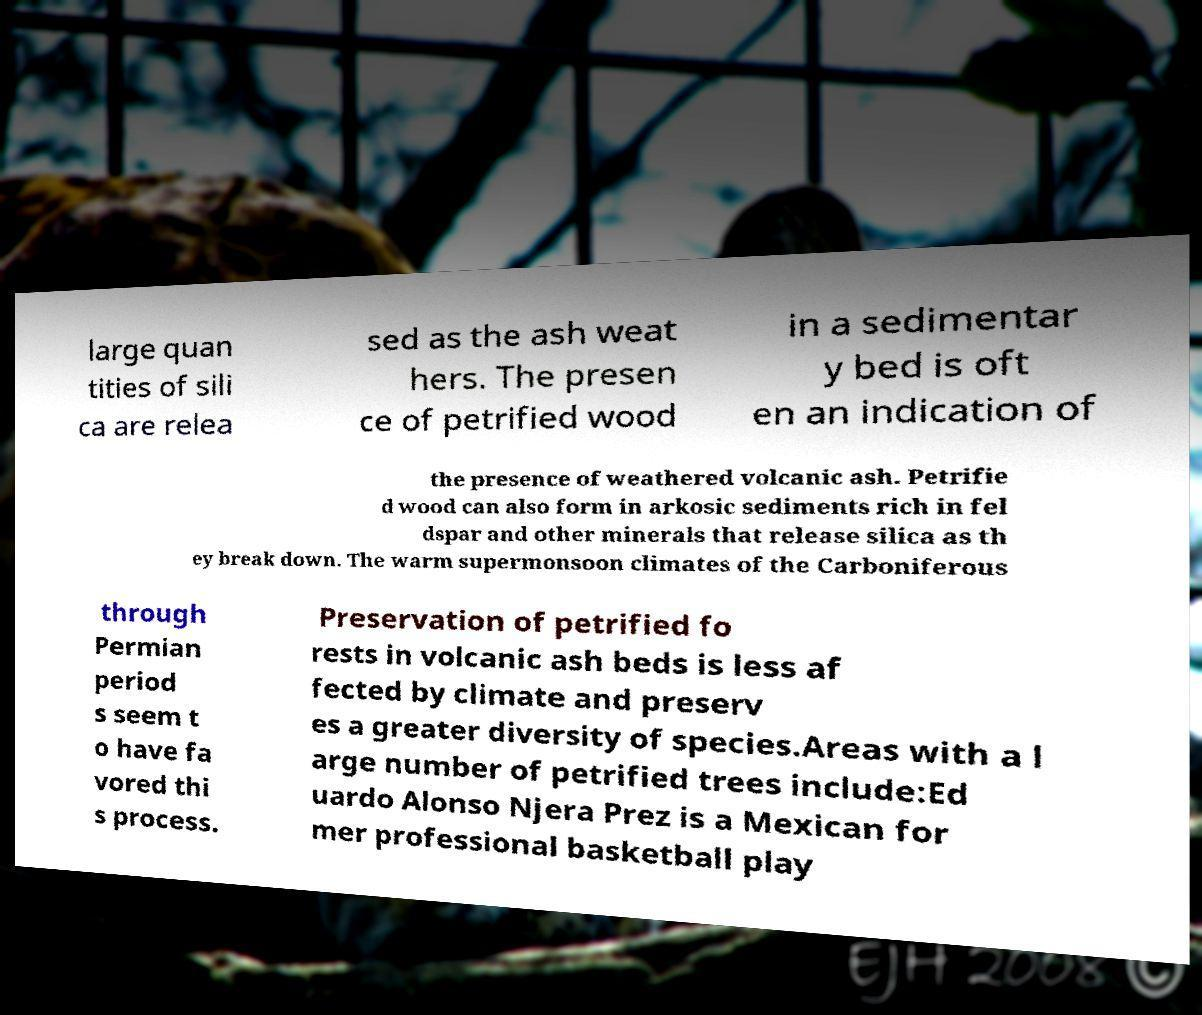Please identify and transcribe the text found in this image. large quan tities of sili ca are relea sed as the ash weat hers. The presen ce of petrified wood in a sedimentar y bed is oft en an indication of the presence of weathered volcanic ash. Petrifie d wood can also form in arkosic sediments rich in fel dspar and other minerals that release silica as th ey break down. The warm supermonsoon climates of the Carboniferous through Permian period s seem t o have fa vored thi s process. Preservation of petrified fo rests in volcanic ash beds is less af fected by climate and preserv es a greater diversity of species.Areas with a l arge number of petrified trees include:Ed uardo Alonso Njera Prez is a Mexican for mer professional basketball play 